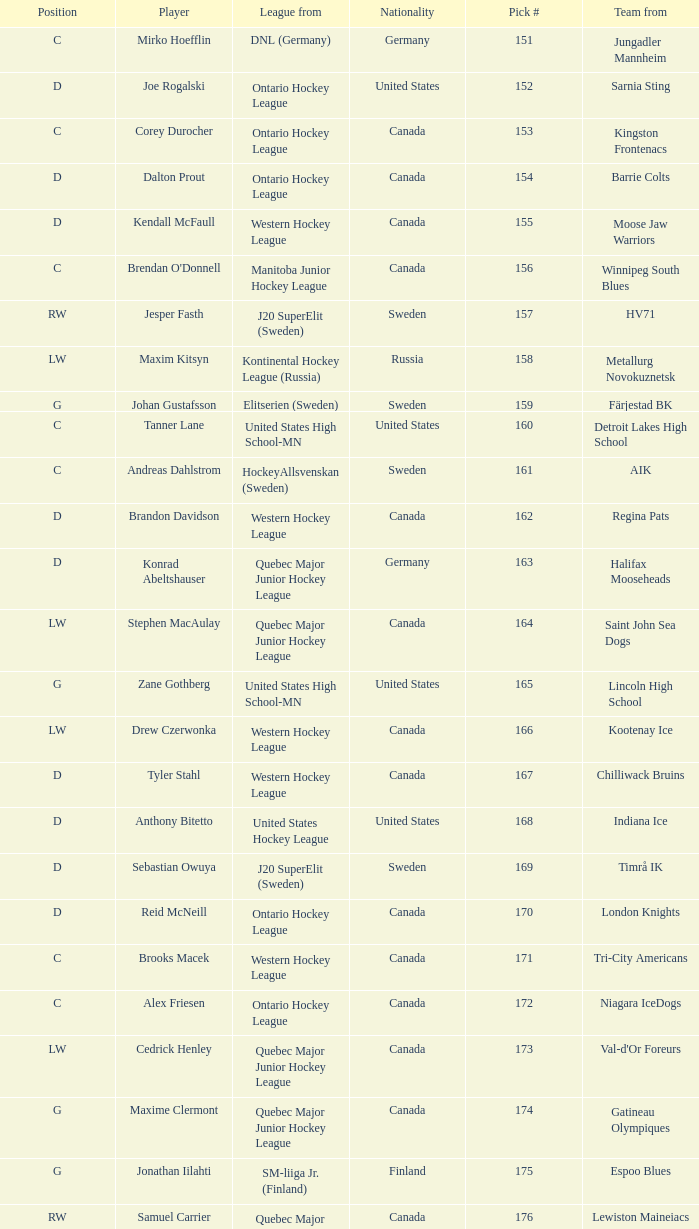What is the total pick # for the D position from a team from Chilliwack Bruins? 167.0. 